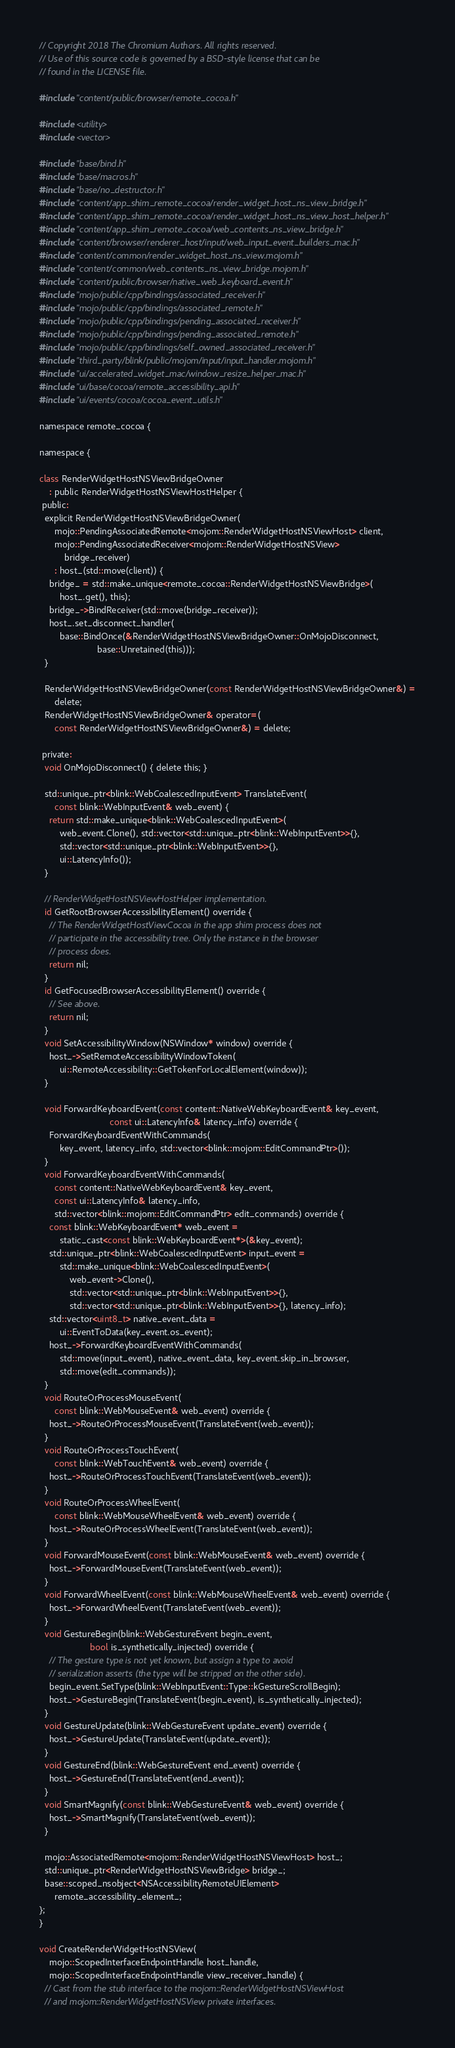<code> <loc_0><loc_0><loc_500><loc_500><_ObjectiveC_>// Copyright 2018 The Chromium Authors. All rights reserved.
// Use of this source code is governed by a BSD-style license that can be
// found in the LICENSE file.

#include "content/public/browser/remote_cocoa.h"

#include <utility>
#include <vector>

#include "base/bind.h"
#include "base/macros.h"
#include "base/no_destructor.h"
#include "content/app_shim_remote_cocoa/render_widget_host_ns_view_bridge.h"
#include "content/app_shim_remote_cocoa/render_widget_host_ns_view_host_helper.h"
#include "content/app_shim_remote_cocoa/web_contents_ns_view_bridge.h"
#include "content/browser/renderer_host/input/web_input_event_builders_mac.h"
#include "content/common/render_widget_host_ns_view.mojom.h"
#include "content/common/web_contents_ns_view_bridge.mojom.h"
#include "content/public/browser/native_web_keyboard_event.h"
#include "mojo/public/cpp/bindings/associated_receiver.h"
#include "mojo/public/cpp/bindings/associated_remote.h"
#include "mojo/public/cpp/bindings/pending_associated_receiver.h"
#include "mojo/public/cpp/bindings/pending_associated_remote.h"
#include "mojo/public/cpp/bindings/self_owned_associated_receiver.h"
#include "third_party/blink/public/mojom/input/input_handler.mojom.h"
#include "ui/accelerated_widget_mac/window_resize_helper_mac.h"
#include "ui/base/cocoa/remote_accessibility_api.h"
#include "ui/events/cocoa/cocoa_event_utils.h"

namespace remote_cocoa {

namespace {

class RenderWidgetHostNSViewBridgeOwner
    : public RenderWidgetHostNSViewHostHelper {
 public:
  explicit RenderWidgetHostNSViewBridgeOwner(
      mojo::PendingAssociatedRemote<mojom::RenderWidgetHostNSViewHost> client,
      mojo::PendingAssociatedReceiver<mojom::RenderWidgetHostNSView>
          bridge_receiver)
      : host_(std::move(client)) {
    bridge_ = std::make_unique<remote_cocoa::RenderWidgetHostNSViewBridge>(
        host_.get(), this);
    bridge_->BindReceiver(std::move(bridge_receiver));
    host_.set_disconnect_handler(
        base::BindOnce(&RenderWidgetHostNSViewBridgeOwner::OnMojoDisconnect,
                       base::Unretained(this)));
  }

  RenderWidgetHostNSViewBridgeOwner(const RenderWidgetHostNSViewBridgeOwner&) =
      delete;
  RenderWidgetHostNSViewBridgeOwner& operator=(
      const RenderWidgetHostNSViewBridgeOwner&) = delete;

 private:
  void OnMojoDisconnect() { delete this; }

  std::unique_ptr<blink::WebCoalescedInputEvent> TranslateEvent(
      const blink::WebInputEvent& web_event) {
    return std::make_unique<blink::WebCoalescedInputEvent>(
        web_event.Clone(), std::vector<std::unique_ptr<blink::WebInputEvent>>{},
        std::vector<std::unique_ptr<blink::WebInputEvent>>{},
        ui::LatencyInfo());
  }

  // RenderWidgetHostNSViewHostHelper implementation.
  id GetRootBrowserAccessibilityElement() override {
    // The RenderWidgetHostViewCocoa in the app shim process does not
    // participate in the accessibility tree. Only the instance in the browser
    // process does.
    return nil;
  }
  id GetFocusedBrowserAccessibilityElement() override {
    // See above.
    return nil;
  }
  void SetAccessibilityWindow(NSWindow* window) override {
    host_->SetRemoteAccessibilityWindowToken(
        ui::RemoteAccessibility::GetTokenForLocalElement(window));
  }

  void ForwardKeyboardEvent(const content::NativeWebKeyboardEvent& key_event,
                            const ui::LatencyInfo& latency_info) override {
    ForwardKeyboardEventWithCommands(
        key_event, latency_info, std::vector<blink::mojom::EditCommandPtr>());
  }
  void ForwardKeyboardEventWithCommands(
      const content::NativeWebKeyboardEvent& key_event,
      const ui::LatencyInfo& latency_info,
      std::vector<blink::mojom::EditCommandPtr> edit_commands) override {
    const blink::WebKeyboardEvent* web_event =
        static_cast<const blink::WebKeyboardEvent*>(&key_event);
    std::unique_ptr<blink::WebCoalescedInputEvent> input_event =
        std::make_unique<blink::WebCoalescedInputEvent>(
            web_event->Clone(),
            std::vector<std::unique_ptr<blink::WebInputEvent>>{},
            std::vector<std::unique_ptr<blink::WebInputEvent>>{}, latency_info);
    std::vector<uint8_t> native_event_data =
        ui::EventToData(key_event.os_event);
    host_->ForwardKeyboardEventWithCommands(
        std::move(input_event), native_event_data, key_event.skip_in_browser,
        std::move(edit_commands));
  }
  void RouteOrProcessMouseEvent(
      const blink::WebMouseEvent& web_event) override {
    host_->RouteOrProcessMouseEvent(TranslateEvent(web_event));
  }
  void RouteOrProcessTouchEvent(
      const blink::WebTouchEvent& web_event) override {
    host_->RouteOrProcessTouchEvent(TranslateEvent(web_event));
  }
  void RouteOrProcessWheelEvent(
      const blink::WebMouseWheelEvent& web_event) override {
    host_->RouteOrProcessWheelEvent(TranslateEvent(web_event));
  }
  void ForwardMouseEvent(const blink::WebMouseEvent& web_event) override {
    host_->ForwardMouseEvent(TranslateEvent(web_event));
  }
  void ForwardWheelEvent(const blink::WebMouseWheelEvent& web_event) override {
    host_->ForwardWheelEvent(TranslateEvent(web_event));
  }
  void GestureBegin(blink::WebGestureEvent begin_event,
                    bool is_synthetically_injected) override {
    // The gesture type is not yet known, but assign a type to avoid
    // serialization asserts (the type will be stripped on the other side).
    begin_event.SetType(blink::WebInputEvent::Type::kGestureScrollBegin);
    host_->GestureBegin(TranslateEvent(begin_event), is_synthetically_injected);
  }
  void GestureUpdate(blink::WebGestureEvent update_event) override {
    host_->GestureUpdate(TranslateEvent(update_event));
  }
  void GestureEnd(blink::WebGestureEvent end_event) override {
    host_->GestureEnd(TranslateEvent(end_event));
  }
  void SmartMagnify(const blink::WebGestureEvent& web_event) override {
    host_->SmartMagnify(TranslateEvent(web_event));
  }

  mojo::AssociatedRemote<mojom::RenderWidgetHostNSViewHost> host_;
  std::unique_ptr<RenderWidgetHostNSViewBridge> bridge_;
  base::scoped_nsobject<NSAccessibilityRemoteUIElement>
      remote_accessibility_element_;
};
}

void CreateRenderWidgetHostNSView(
    mojo::ScopedInterfaceEndpointHandle host_handle,
    mojo::ScopedInterfaceEndpointHandle view_receiver_handle) {
  // Cast from the stub interface to the mojom::RenderWidgetHostNSViewHost
  // and mojom::RenderWidgetHostNSView private interfaces.</code> 